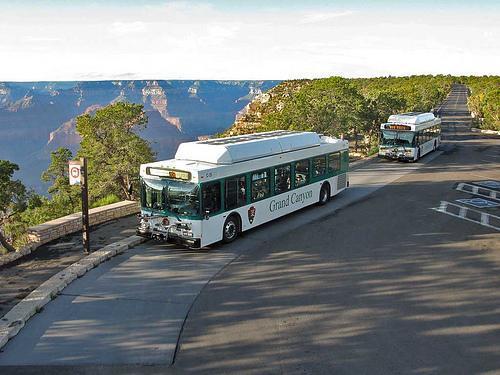How many windows panes are on the front of the bus?
Give a very brief answer. 2. How many buses are there?
Give a very brief answer. 2. How many signs are there?
Give a very brief answer. 1. How many buses are in the picture?
Give a very brief answer. 2. How many people are in this picture?
Give a very brief answer. 0. How many signs are in this picture?
Give a very brief answer. 1. 